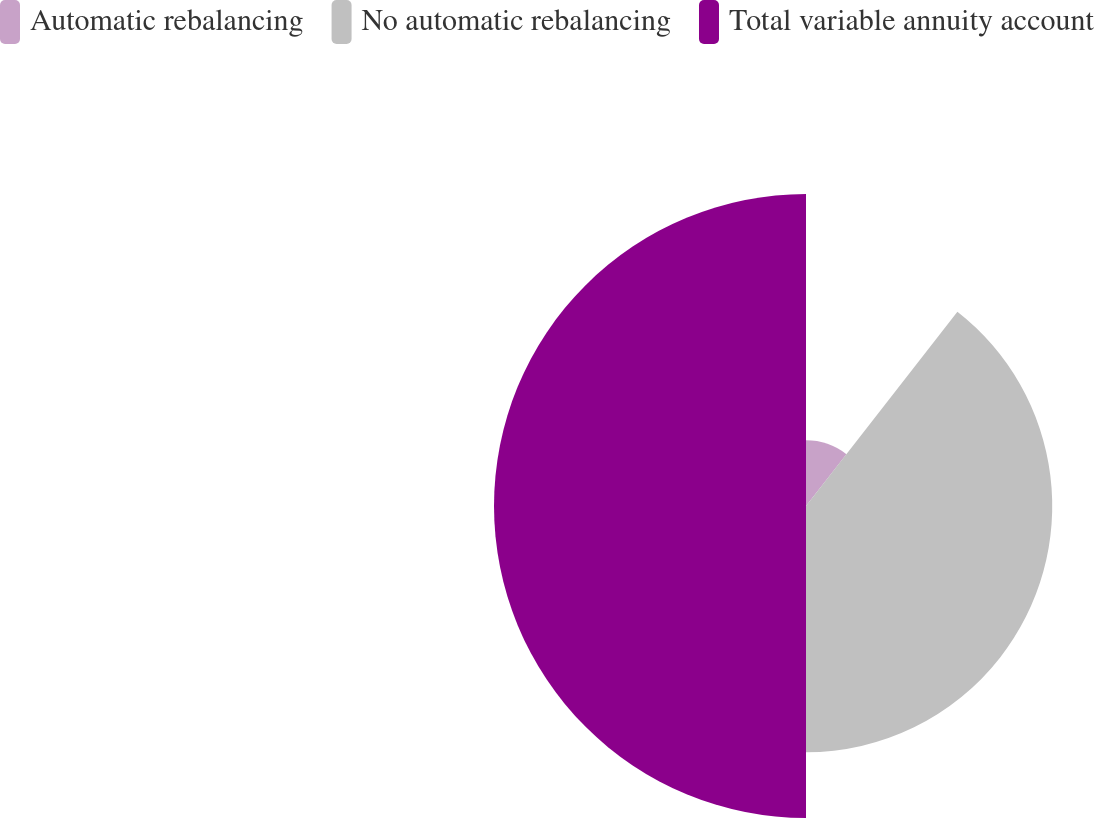Convert chart to OTSL. <chart><loc_0><loc_0><loc_500><loc_500><pie_chart><fcel>Automatic rebalancing<fcel>No automatic rebalancing<fcel>Total variable annuity account<nl><fcel>10.54%<fcel>39.46%<fcel>50.0%<nl></chart> 